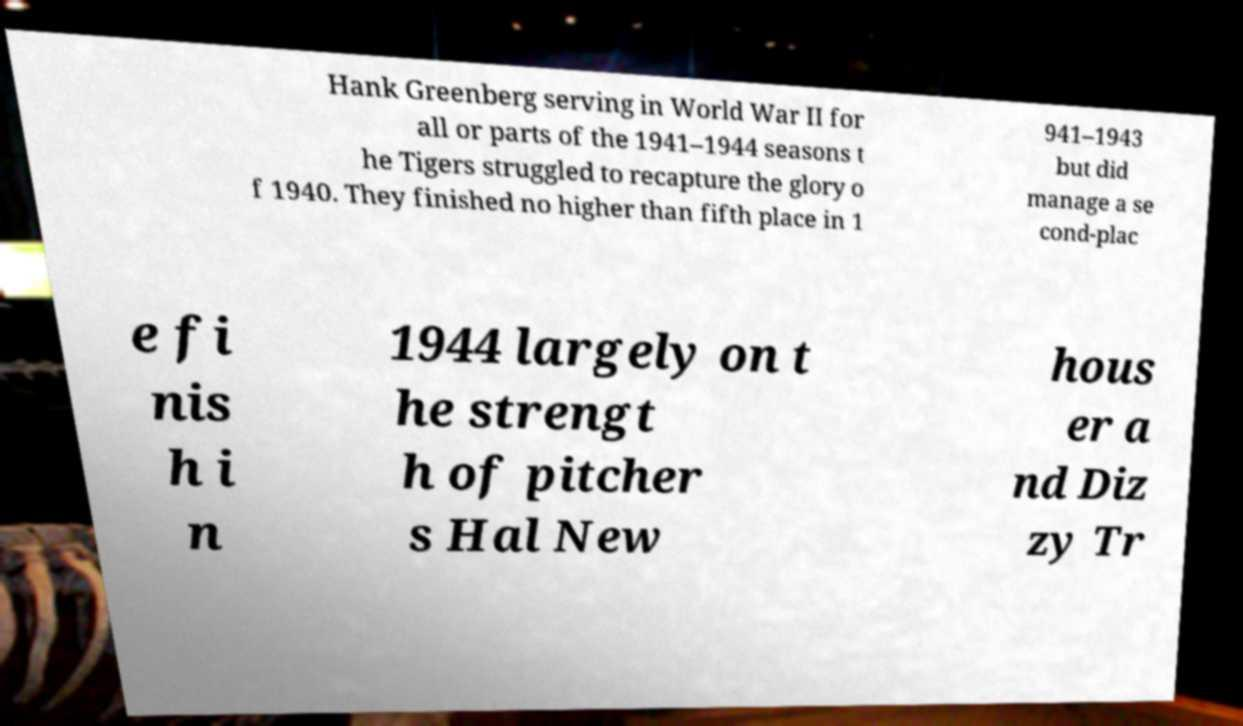Please identify and transcribe the text found in this image. Hank Greenberg serving in World War II for all or parts of the 1941–1944 seasons t he Tigers struggled to recapture the glory o f 1940. They finished no higher than fifth place in 1 941–1943 but did manage a se cond-plac e fi nis h i n 1944 largely on t he strengt h of pitcher s Hal New hous er a nd Diz zy Tr 